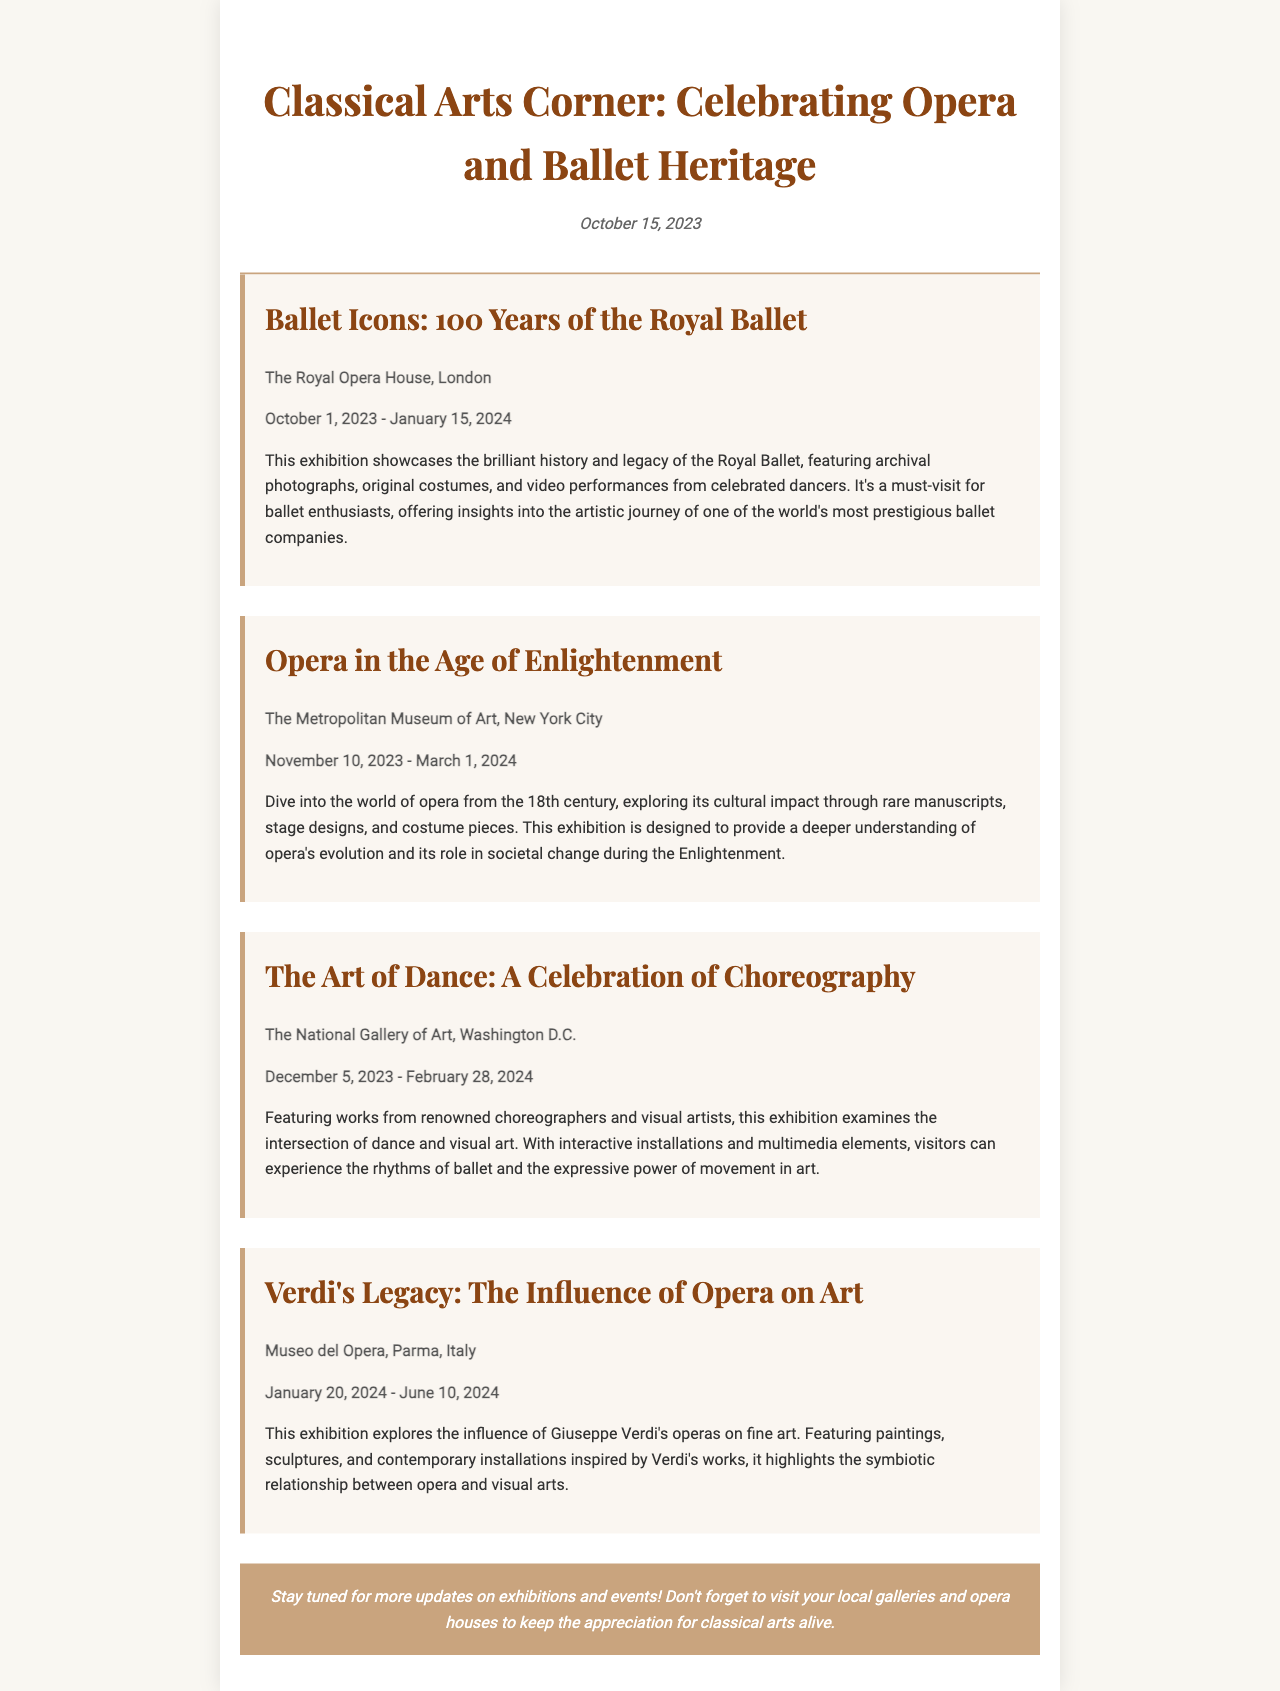What is the title of the exhibition at The Royal Opera House? The title of the exhibition is mentioned in the document as "Ballet Icons: 100 Years of the Royal Ballet."
Answer: Ballet Icons: 100 Years of the Royal Ballet What is the end date of "Opera in the Age of Enlightenment"? The end date for this exhibition is indicated as March 1, 2024.
Answer: March 1, 2024 Where is "The Art of Dance: A Celebration of Choreography" being held? The venue for this exhibition is listed in the document as The National Gallery of Art, Washington D.C.
Answer: The National Gallery of Art, Washington D.C How long does the "Verdi's Legacy: The Influence of Opera on Art" exhibition run? By subtracting the start date of January 20, 2024, from the end date of June 10, 2024, we can determine that the exhibition runs for approximately 145 days.
Answer: 145 days What is the main theme of "Opera in the Age of Enlightenment"? The theme is summarized in the document as exploring opera's cultural impact through manuscripts, stage designs, and costume pieces.
Answer: Cultural impact of opera What month does "Ballet Icons: 100 Years of the Royal Ballet" start? The document specifically states that this exhibition starts in October.
Answer: October Which exhibition is focused on the legacy of Verdi? The document specifies that "Verdi's Legacy: The Influence of Opera on Art" is focused on Verdi's legacy.
Answer: Verdi's Legacy: The Influence of Opera on Art What type of elements are included in "The Art of Dance" exhibition? The document mentions that the exhibition features interactive installations and multimedia elements.
Answer: Interactive installations and multimedia elements What is the purpose of the newsletter? The purpose is to update readers on exhibitions and events celebrating classical arts, specifically opera and ballet heritage.
Answer: Update on classical arts exhibitions 